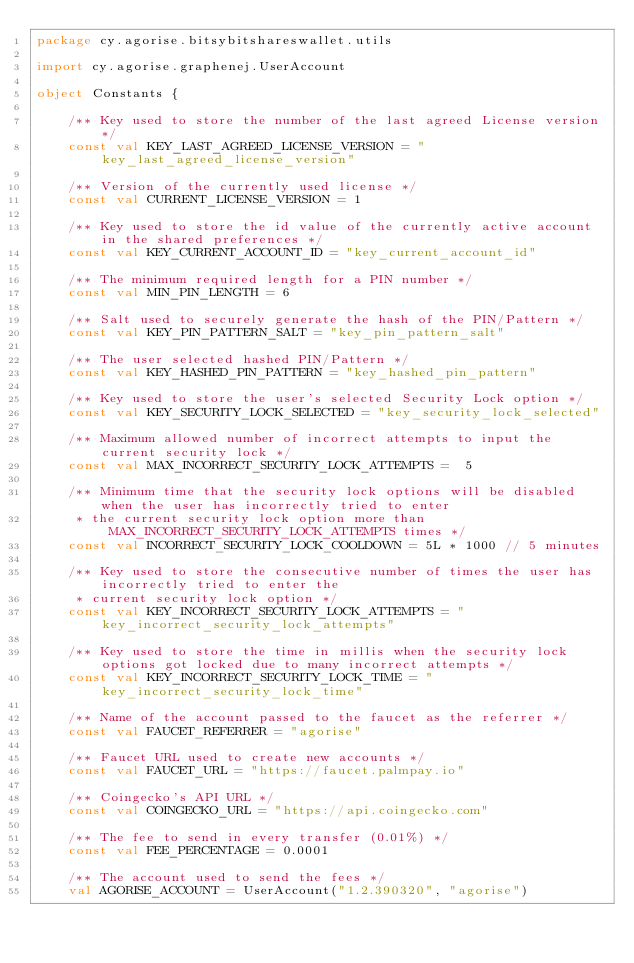Convert code to text. <code><loc_0><loc_0><loc_500><loc_500><_Kotlin_>package cy.agorise.bitsybitshareswallet.utils

import cy.agorise.graphenej.UserAccount

object Constants {

    /** Key used to store the number of the last agreed License version */
    const val KEY_LAST_AGREED_LICENSE_VERSION = "key_last_agreed_license_version"

    /** Version of the currently used license */
    const val CURRENT_LICENSE_VERSION = 1

    /** Key used to store the id value of the currently active account in the shared preferences */
    const val KEY_CURRENT_ACCOUNT_ID = "key_current_account_id"

    /** The minimum required length for a PIN number */
    const val MIN_PIN_LENGTH = 6

    /** Salt used to securely generate the hash of the PIN/Pattern */
    const val KEY_PIN_PATTERN_SALT = "key_pin_pattern_salt"

    /** The user selected hashed PIN/Pattern */
    const val KEY_HASHED_PIN_PATTERN = "key_hashed_pin_pattern"

    /** Key used to store the user's selected Security Lock option */
    const val KEY_SECURITY_LOCK_SELECTED = "key_security_lock_selected"

    /** Maximum allowed number of incorrect attempts to input the current security lock */
    const val MAX_INCORRECT_SECURITY_LOCK_ATTEMPTS =  5

    /** Minimum time that the security lock options will be disabled when the user has incorrectly tried to enter
     * the current security lock option more than MAX_INCORRECT_SECURITY_LOCK_ATTEMPTS times */
    const val INCORRECT_SECURITY_LOCK_COOLDOWN = 5L * 1000 // 5 minutes

    /** Key used to store the consecutive number of times the user has incorrectly tried to enter the
     * current security lock option */
    const val KEY_INCORRECT_SECURITY_LOCK_ATTEMPTS = "key_incorrect_security_lock_attempts"

    /** Key used to store the time in millis when the security lock options got locked due to many incorrect attempts */
    const val KEY_INCORRECT_SECURITY_LOCK_TIME = "key_incorrect_security_lock_time"

    /** Name of the account passed to the faucet as the referrer */
    const val FAUCET_REFERRER = "agorise"

    /** Faucet URL used to create new accounts */
    const val FAUCET_URL = "https://faucet.palmpay.io"

    /** Coingecko's API URL */
    const val COINGECKO_URL = "https://api.coingecko.com"

    /** The fee to send in every transfer (0.01%) */
    const val FEE_PERCENTAGE = 0.0001

    /** The account used to send the fees */
    val AGORISE_ACCOUNT = UserAccount("1.2.390320", "agorise")
</code> 